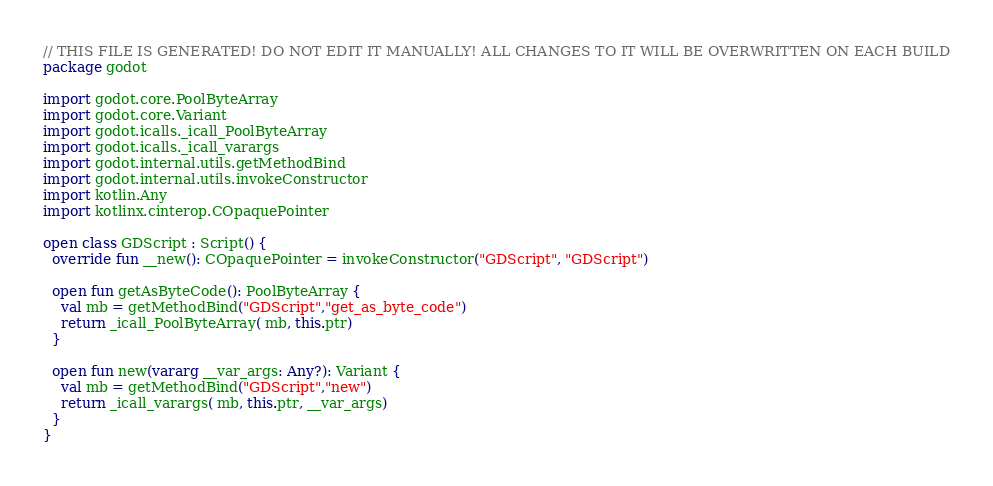<code> <loc_0><loc_0><loc_500><loc_500><_Kotlin_>// THIS FILE IS GENERATED! DO NOT EDIT IT MANUALLY! ALL CHANGES TO IT WILL BE OVERWRITTEN ON EACH BUILD
package godot

import godot.core.PoolByteArray
import godot.core.Variant
import godot.icalls._icall_PoolByteArray
import godot.icalls._icall_varargs
import godot.internal.utils.getMethodBind
import godot.internal.utils.invokeConstructor
import kotlin.Any
import kotlinx.cinterop.COpaquePointer

open class GDScript : Script() {
  override fun __new(): COpaquePointer = invokeConstructor("GDScript", "GDScript")

  open fun getAsByteCode(): PoolByteArray {
    val mb = getMethodBind("GDScript","get_as_byte_code")
    return _icall_PoolByteArray( mb, this.ptr)
  }

  open fun new(vararg __var_args: Any?): Variant {
    val mb = getMethodBind("GDScript","new")
    return _icall_varargs( mb, this.ptr, __var_args)
  }
}
</code> 